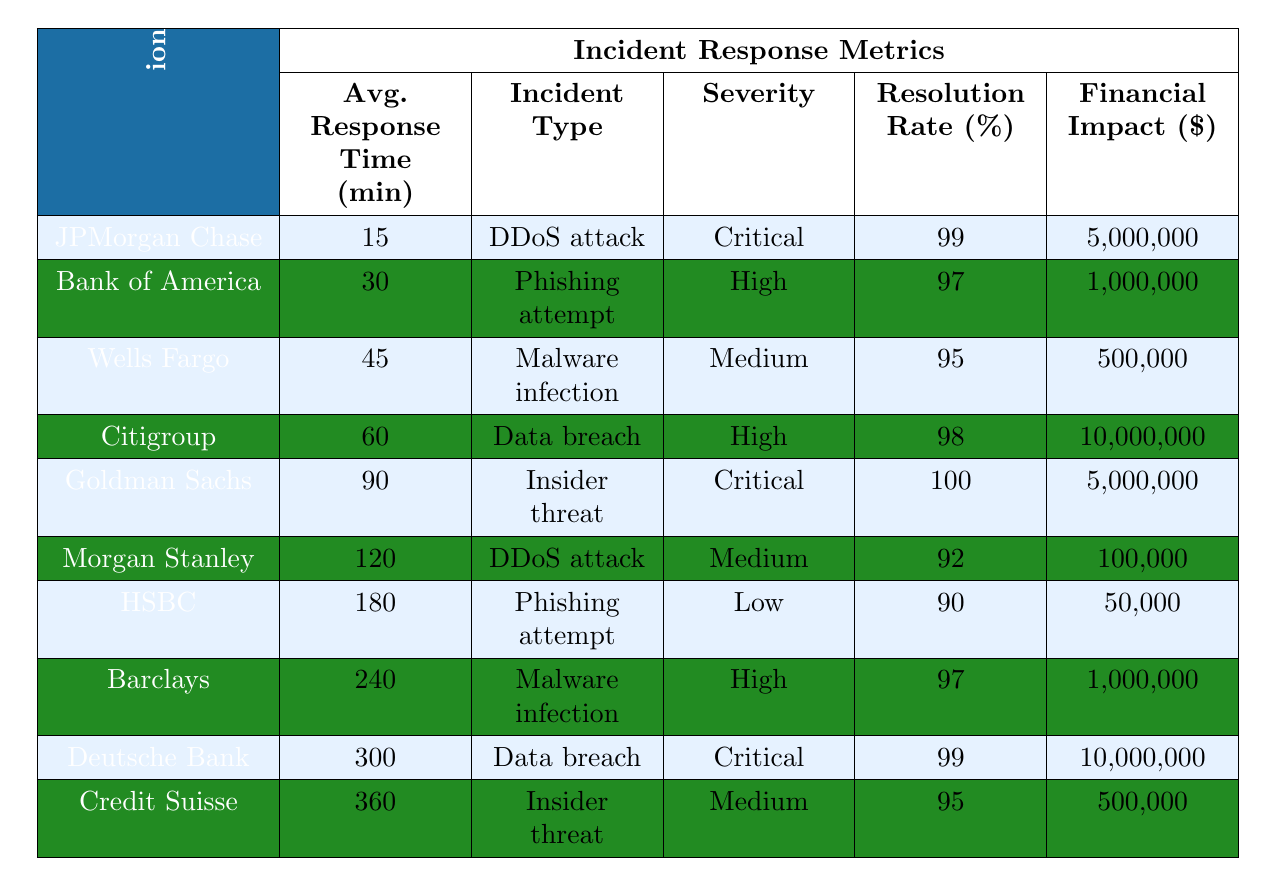What is the average response time for incidents across all organizations? To find the average response time, we need to sum all the average response times for each organization and divide by the number of organizations (10). The total response time is \(15 + 30 + 45 + 60 + 90 + 120 + 180 + 240 + 300 + 360 = 1390\). Dividing this by 10 gives \(1390 / 10 = 139\).
Answer: 139 Which organization took the longest to respond and what was their response time? By examining the response times listed, Credit Suisse has the longest response time at 360 minutes.
Answer: Credit Suisse, 360 minutes Is the resolution rate for Goldman Sachs higher than 95%? Goldman Sachs has a resolution rate of 100%, which is higher than 95%.
Answer: Yes What is the financial impact of the incident type with the highest average response time? The incident type with the highest response time is Credit Suisse with 360 minutes which corresponds to an insider threat with a financial impact of $500,000.
Answer: $500,000 Which organization had a critical severity rating and what was their average response time? The organizations with critical severity ratings are JPMorgan Chase (15 minutes) and Goldman Sachs (90 minutes).
Answer: JPMorgan Chase, 15 minutes; Goldman Sachs, 90 minutes How many organizations reported a resolution rate of 99% or above? The organizations with a resolution rate of 99% or above are JPMorgan Chase (99%), Goldman Sachs (100%), Deutsche Bank (99%), and Citigroup (98%). That's four organizations.
Answer: 4 Is the average response time for data breaches higher than the average response time for phishing attempts? The average response time for data breaches (Citigroup: 60 mins, Deutsche Bank: 300 mins) is \( (60 + 300) / 2 = 180\) minutes, and for phishing attempts (Bank of America: 30 mins, HSBC: 180 mins) is \( (30 + 180) / 2 = 105\) minutes. Since 180 > 105, the average response time for data breaches is indeed higher.
Answer: Yes What is the total financial impact represented by all organizations? To find the total financial impact, we sum all the values: \(5,000,000 + 1,000,000 + 500,000 + 10,000,000 + 5,000,000 + 100,000 + 50,000 + 1,000,000 + 10,000,000 + 500,000 = 33,150,000\).
Answer: $33,150,000 Do any organizations have a lower-than-average response time? The average response time is determined to be 139 minutes. The organizations with lower response times are JPMorgan Chase (15 mins), Bank of America (30 mins), and Wells Fargo (45 mins). Yes, they have response times below the average.
Answer: Yes What is the incident type that corresponds with the lowest average response time? The incident type that corresponds with the lowest average response time is Critical with JPMorgan Chase (15 minutes) experiencing a DDoS attack.
Answer: DDoS attack, 15 minutes 